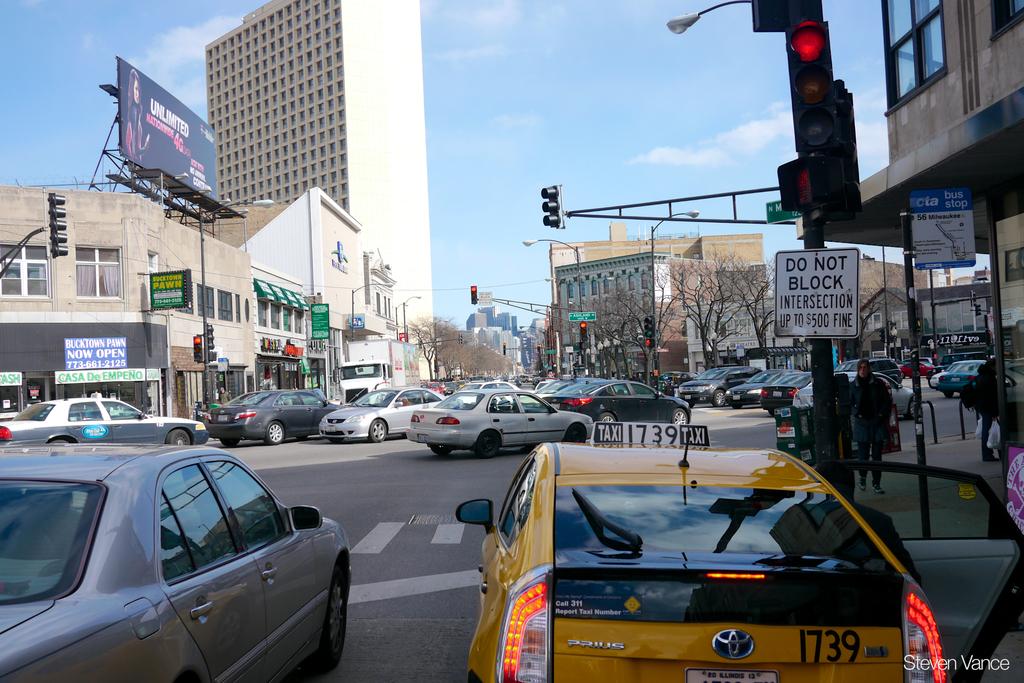What is the taxi's number?
Offer a terse response. 1739. What is the fine for blocking the intersection?
Give a very brief answer. $500. 